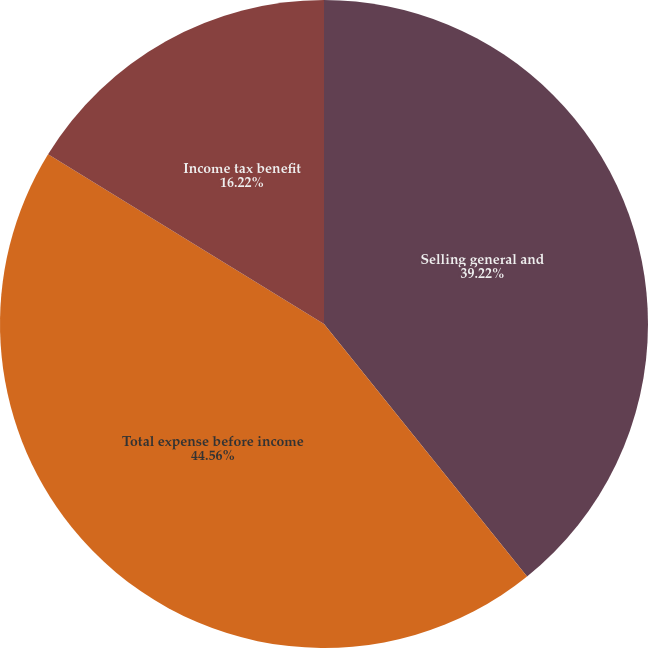<chart> <loc_0><loc_0><loc_500><loc_500><pie_chart><fcel>Selling general and<fcel>Total expense before income<fcel>Income tax benefit<nl><fcel>39.22%<fcel>44.56%<fcel>16.22%<nl></chart> 